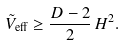<formula> <loc_0><loc_0><loc_500><loc_500>\tilde { V } _ { \text {eff} } \geq \frac { D - 2 } { 2 } \, H ^ { 2 } .</formula> 